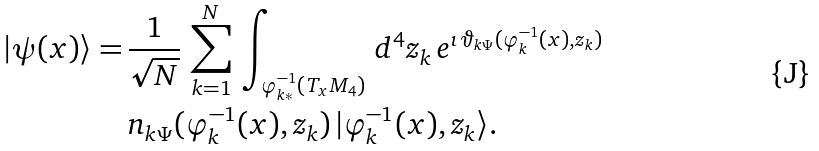<formula> <loc_0><loc_0><loc_500><loc_500>| \psi ( x ) \rangle = & \, \frac { 1 } { \sqrt { N } } \, \sum ^ { N } _ { k = 1 } \, \int _ { \varphi ^ { - 1 } _ { k * } ( T _ { x } M _ { 4 } ) } \, d ^ { 4 } z _ { k } \, e ^ { \imath \, \vartheta _ { k \Psi } ( \varphi ^ { - 1 } _ { k } ( x ) , z _ { k } ) } \\ & \, n _ { k \Psi } ( \varphi ^ { - 1 } _ { k } ( x ) , z _ { k } ) \, | \varphi ^ { - 1 } _ { k } ( x ) , z _ { k } \rangle .</formula> 